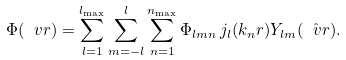Convert formula to latex. <formula><loc_0><loc_0><loc_500><loc_500>\Phi ( \ v r ) = \sum _ { l = 1 } ^ { l _ { \max } } \sum _ { m = - l } ^ { l } \sum _ { n = 1 } ^ { n _ { \max } } \Phi _ { l m n } \, j _ { l } ( k _ { n } r ) Y _ { l m } ( \hat { \ v r } ) .</formula> 